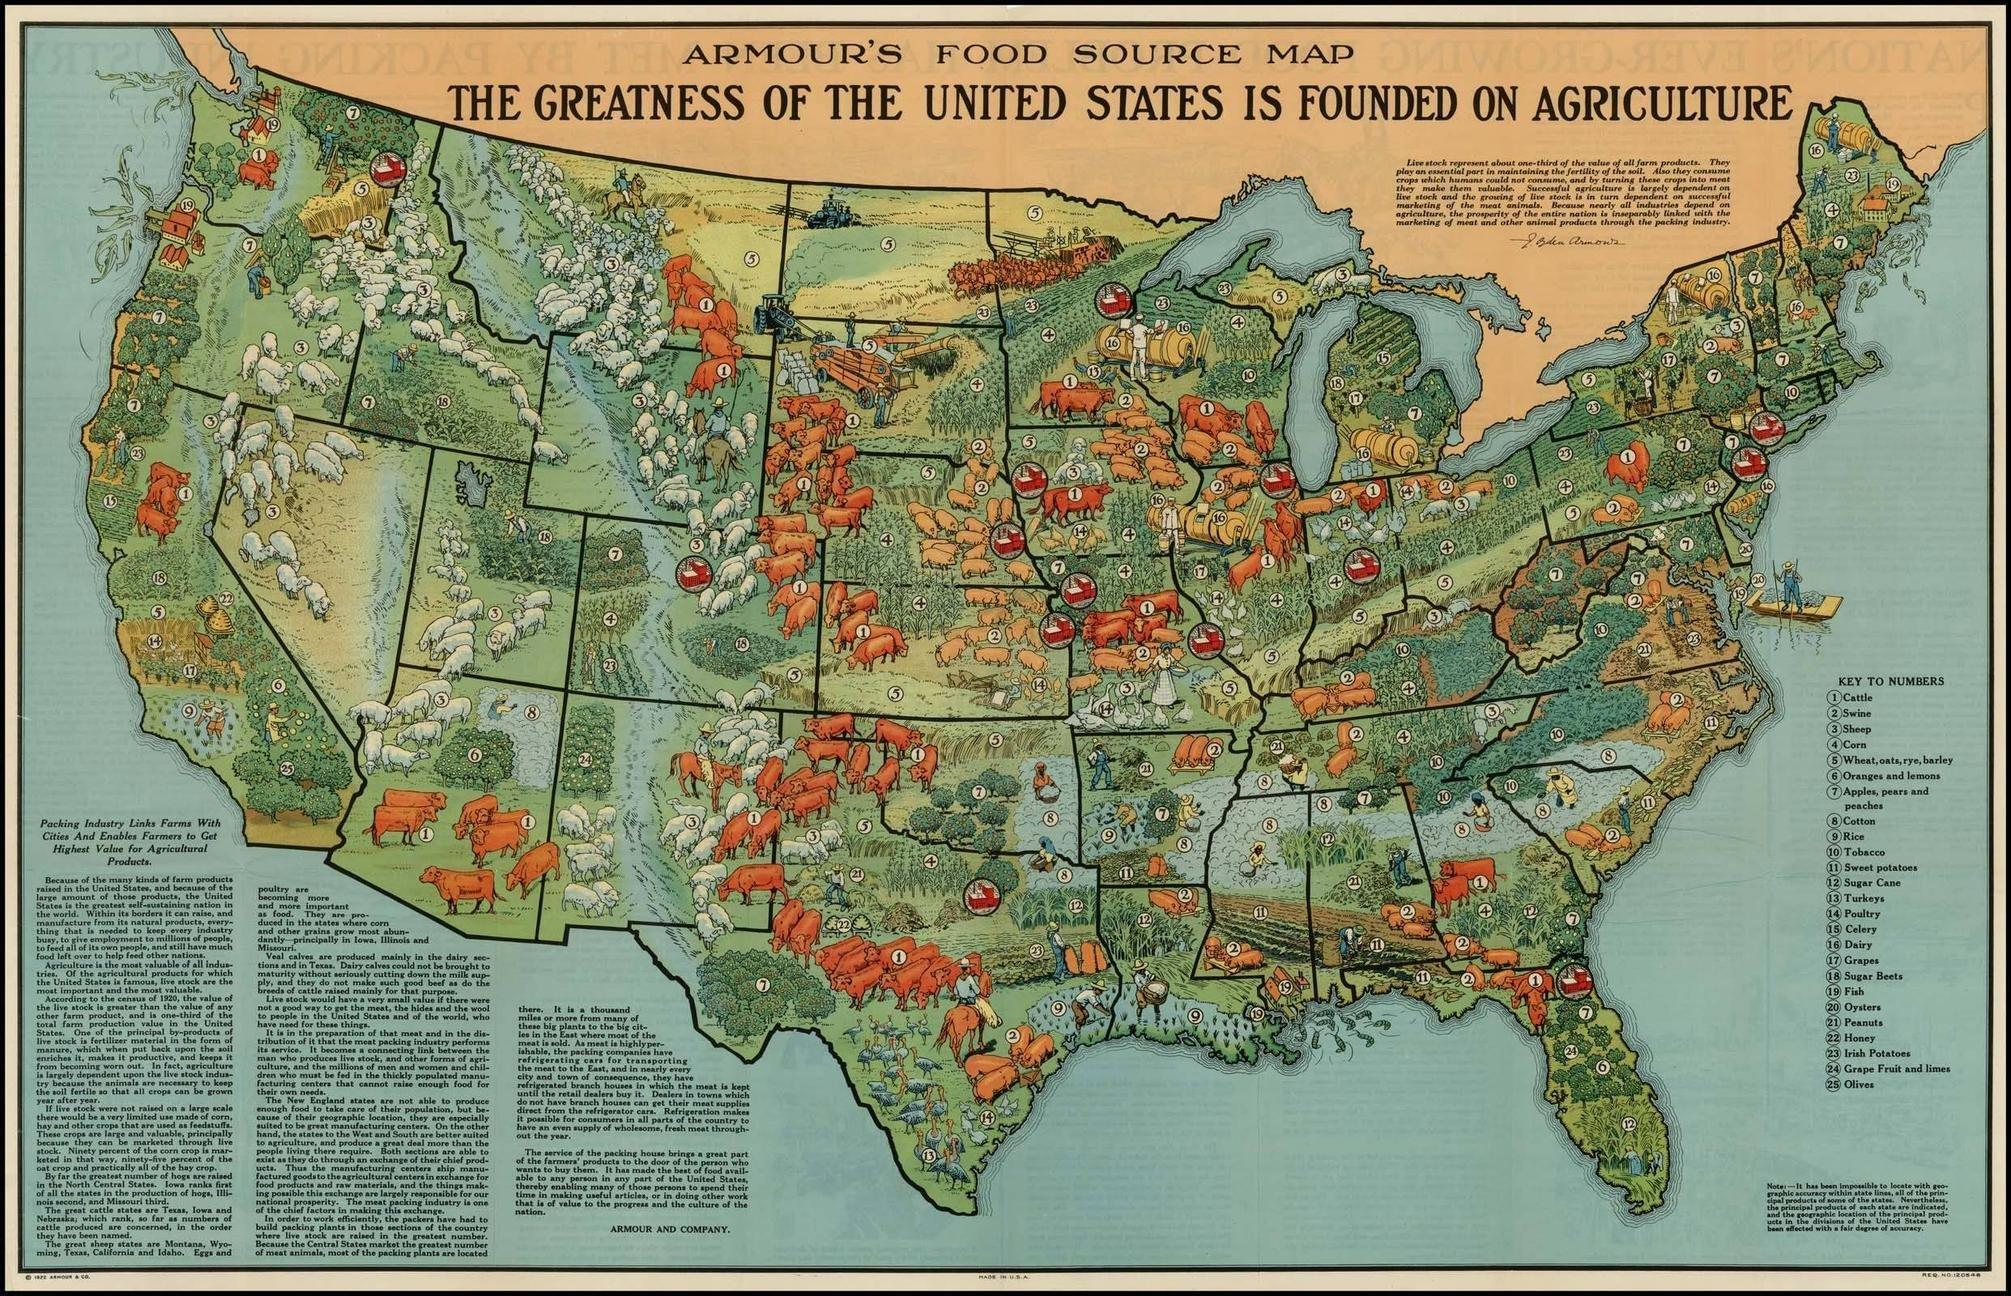List a handful of essential elements in this visual. Veal calves are primarily produced in the dairy section and in Texas, using intensive breeding and feeding methods to reduce their growth and size. There are 25 different items plotted on this map. 